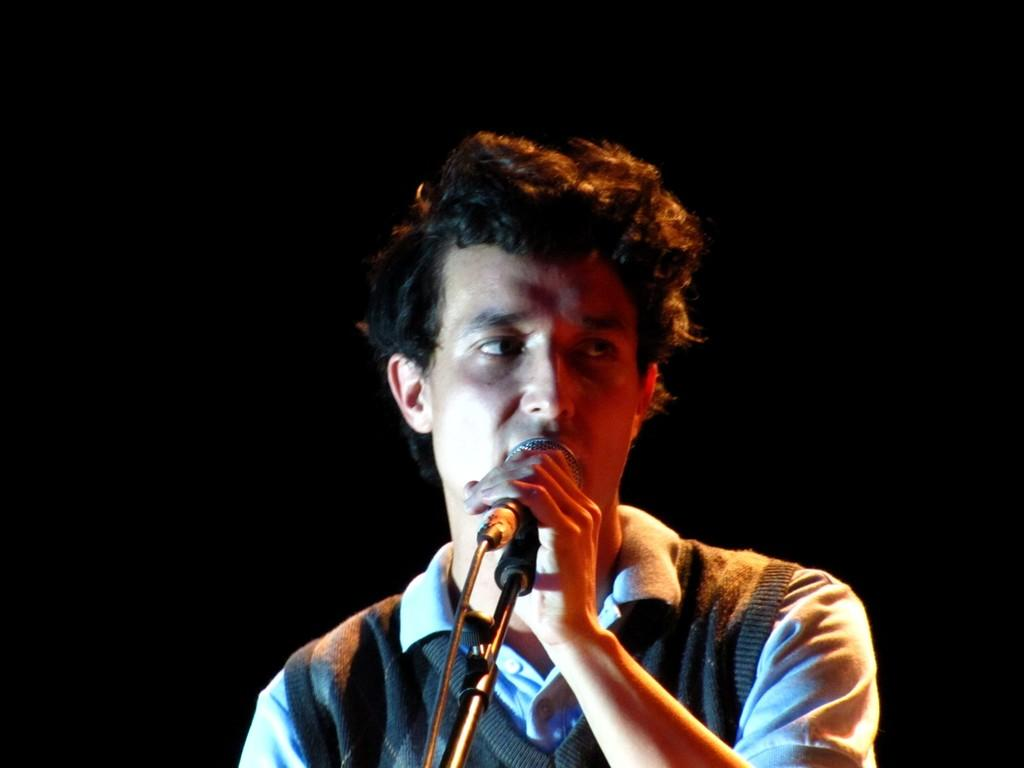What is the main subject of the image? The main subject of the image is a man. What is the man doing in the image? The man is standing in the image. What object is the man holding in the image? The man is holding a microphone in the image. What is the man's father doing in the image? There is no information about the man's father in the image, so we cannot answer this question. 